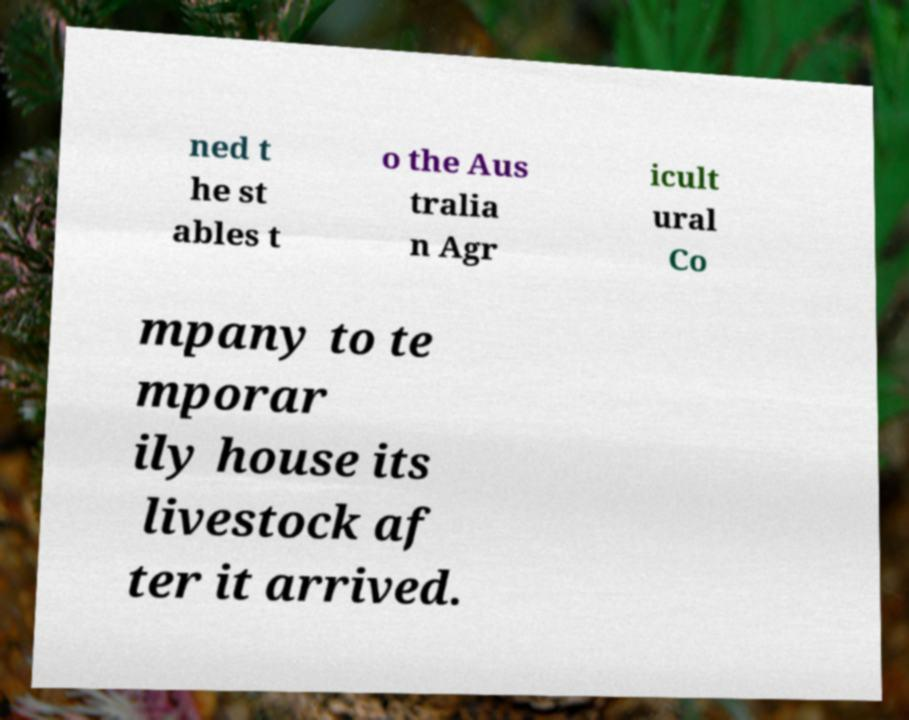For documentation purposes, I need the text within this image transcribed. Could you provide that? ned t he st ables t o the Aus tralia n Agr icult ural Co mpany to te mporar ily house its livestock af ter it arrived. 